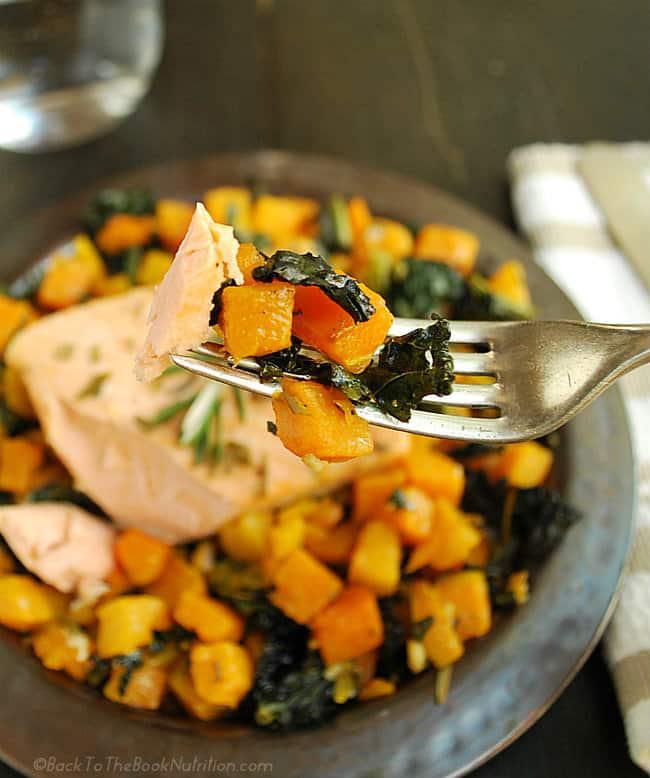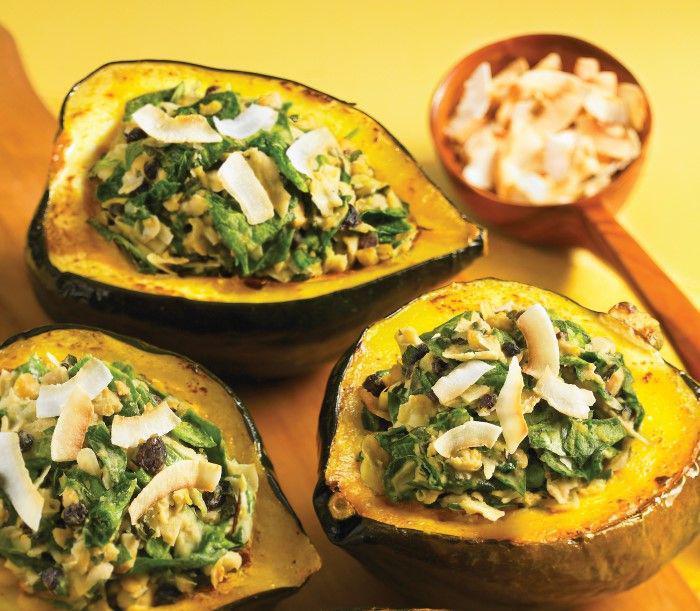The first image is the image on the left, the second image is the image on the right. Evaluate the accuracy of this statement regarding the images: "Some of the squash in the image on the left sit on a black tray.". Is it true? Answer yes or no. No. 